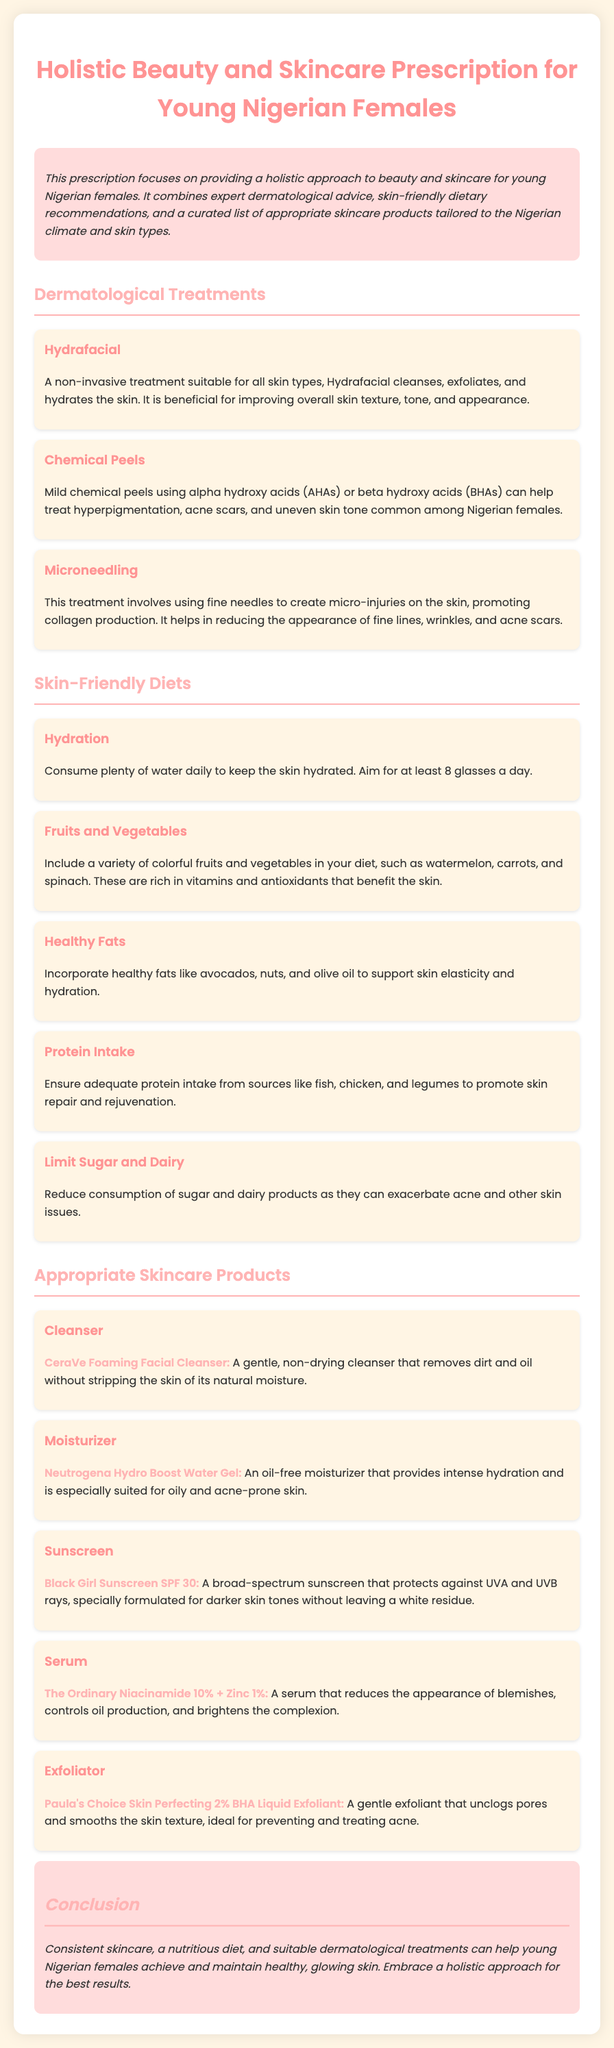What is the title of the document? The title is a descriptive phrase that summarizes the content of the document.
Answer: Holistic Beauty and Skincare Prescription for Young Nigerian Females What is one dermatological treatment mentioned? The document lists multiple treatments; selecting one provides specific details.
Answer: Hydrafacial How many glasses of water should one aim to consume daily? The document provides a specific guideline related to hydration for the skin.
Answer: at least 8 Which food type should be limited to benefit the skin? The document mentions specific dietary restrictions related to skin health.
Answer: Sugar and Dairy What is a recommended moisturizer from the document? This request looks for a product name mentioned in the appropriate products section.
Answer: Neutrogena Hydro Boost Water Gel What is one benefit of the Hydrafacial treatment? The document highlights specific advantages related to skin appearance and health.
Answer: Improves overall skin texture What type of acid is used in mild chemical peels? The document specifies types of acids used for treatment.
Answer: Alpha hydroxy acids (AHAs) What is the purpose of the concluding section? The conclusion summarizes the goals and approaches for skincare mentioned in the document.
Answer: To emphasize a holistic approach Which vitamin-rich foods are recommended for skin health? The document suggests various dietary options that benefit skin condition.
Answer: Colorful fruits and vegetables 